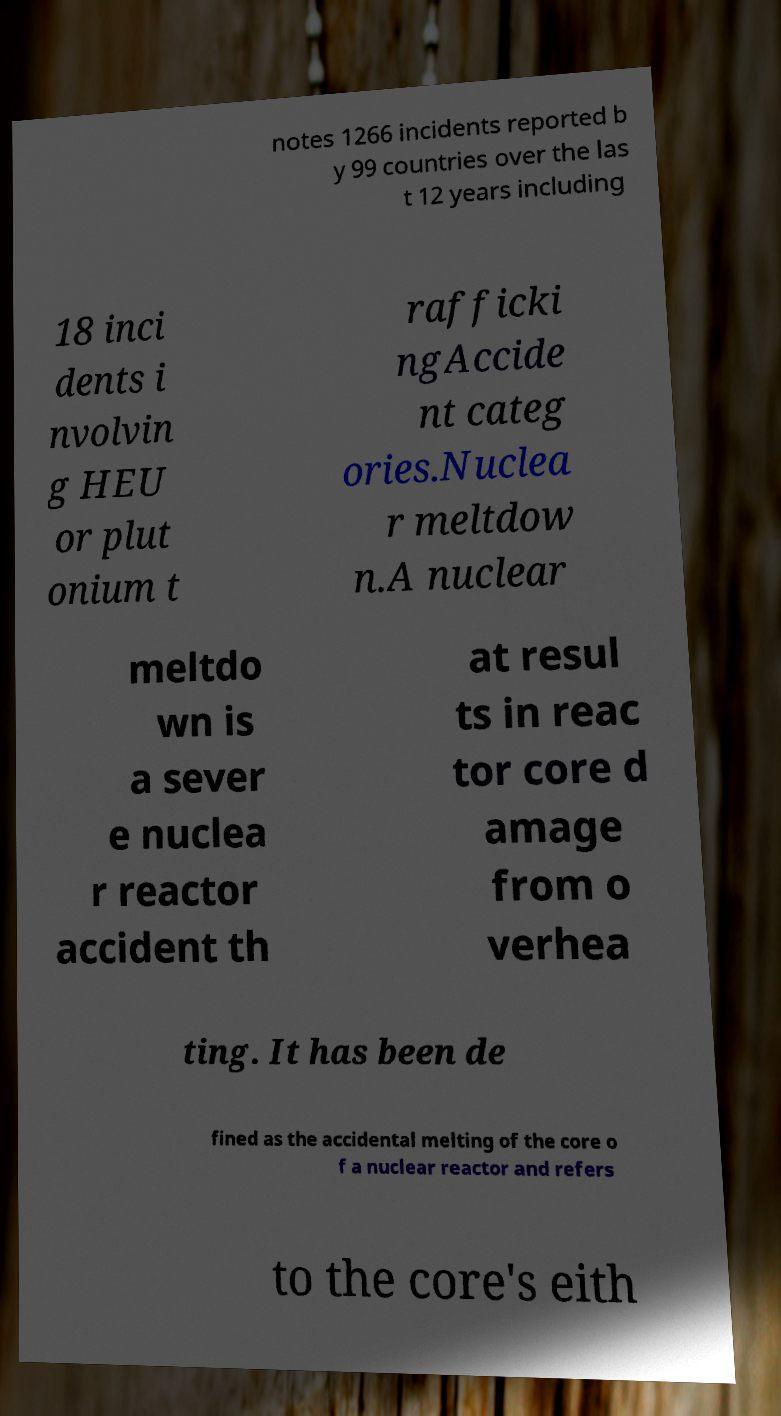Could you extract and type out the text from this image? notes 1266 incidents reported b y 99 countries over the las t 12 years including 18 inci dents i nvolvin g HEU or plut onium t rafficki ngAccide nt categ ories.Nuclea r meltdow n.A nuclear meltdo wn is a sever e nuclea r reactor accident th at resul ts in reac tor core d amage from o verhea ting. It has been de fined as the accidental melting of the core o f a nuclear reactor and refers to the core's eith 